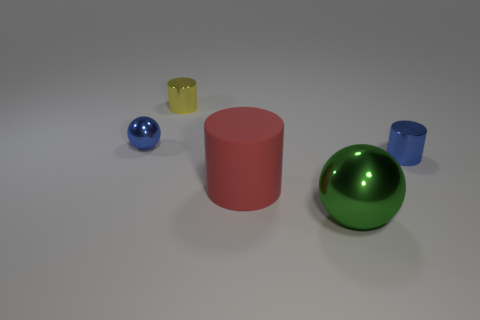Do the objects share any similarities in terms of texture? The objects showcased have varying textures. The green and blue spheres have a glossy finish, the yellow cup appears translucent, and the red cylindrical object has a matte finish. 